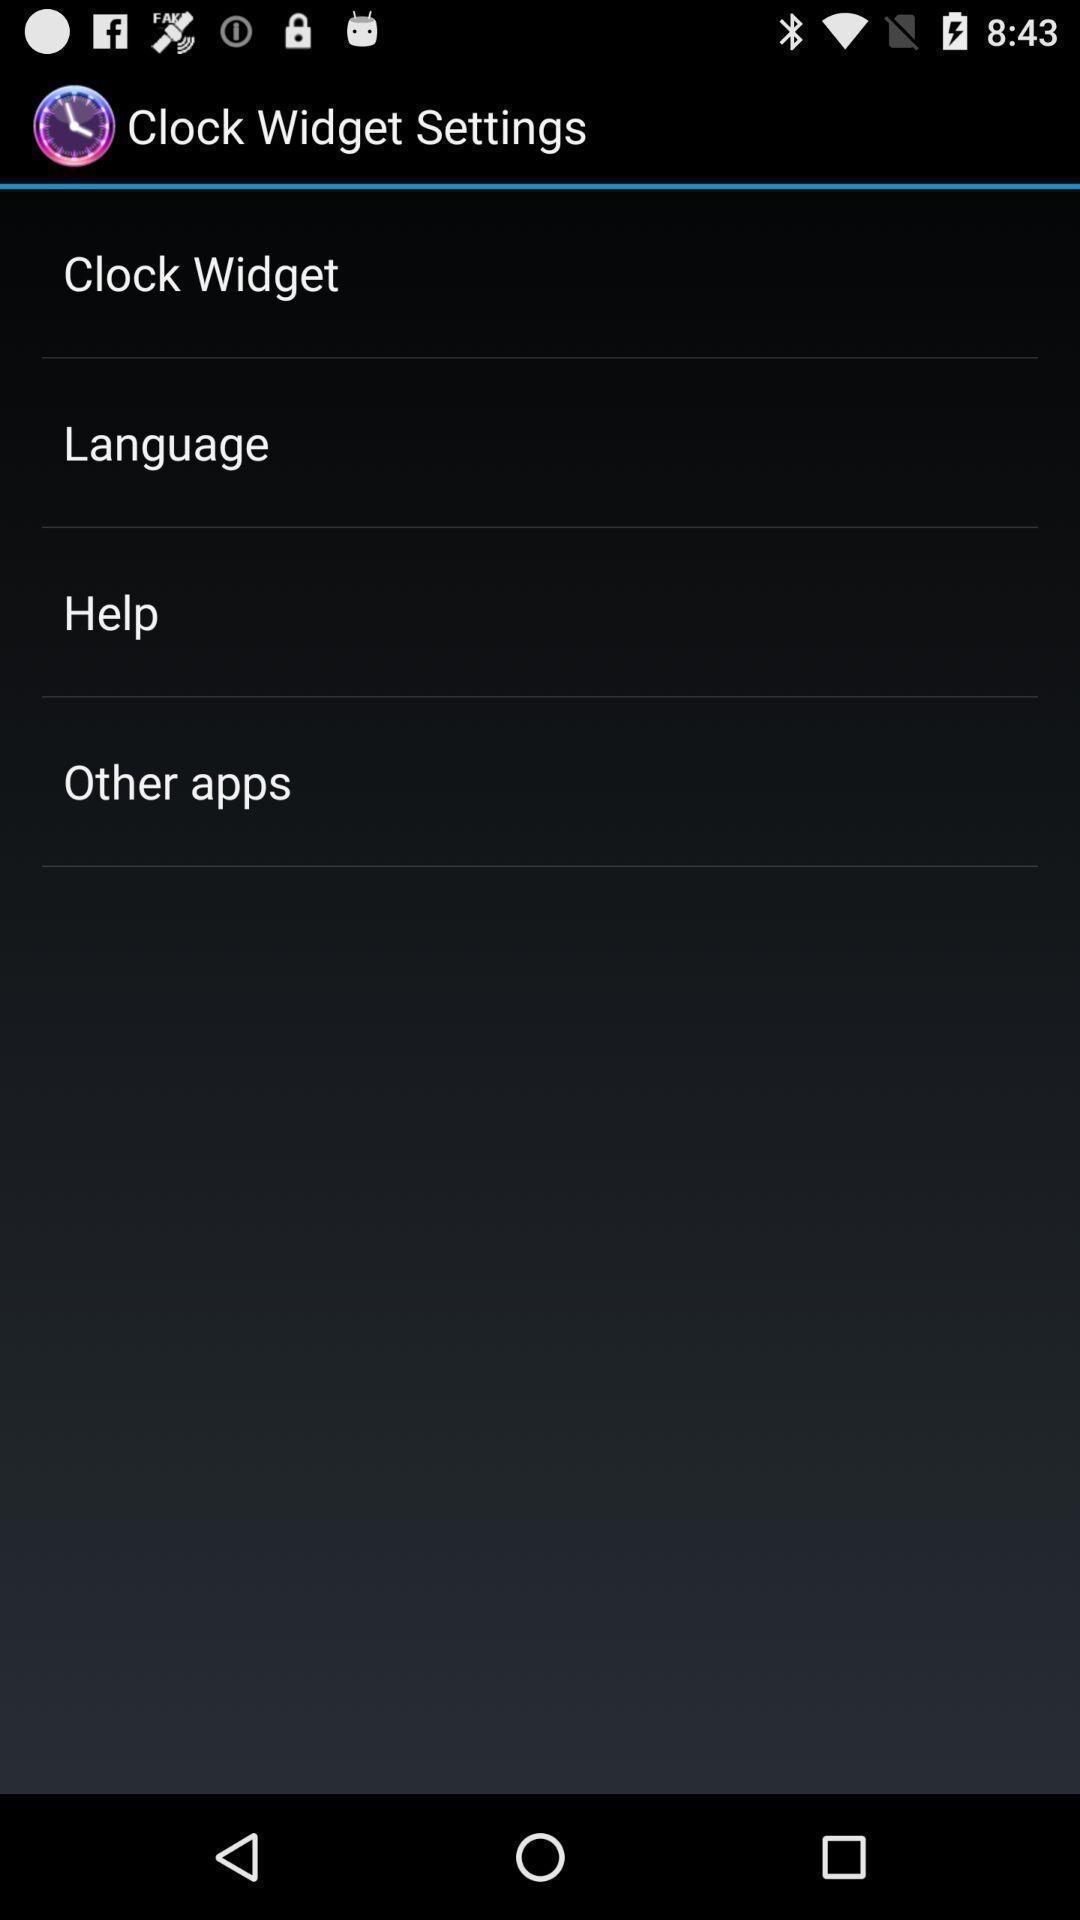Give me a narrative description of this picture. Page displaying various settings options. 